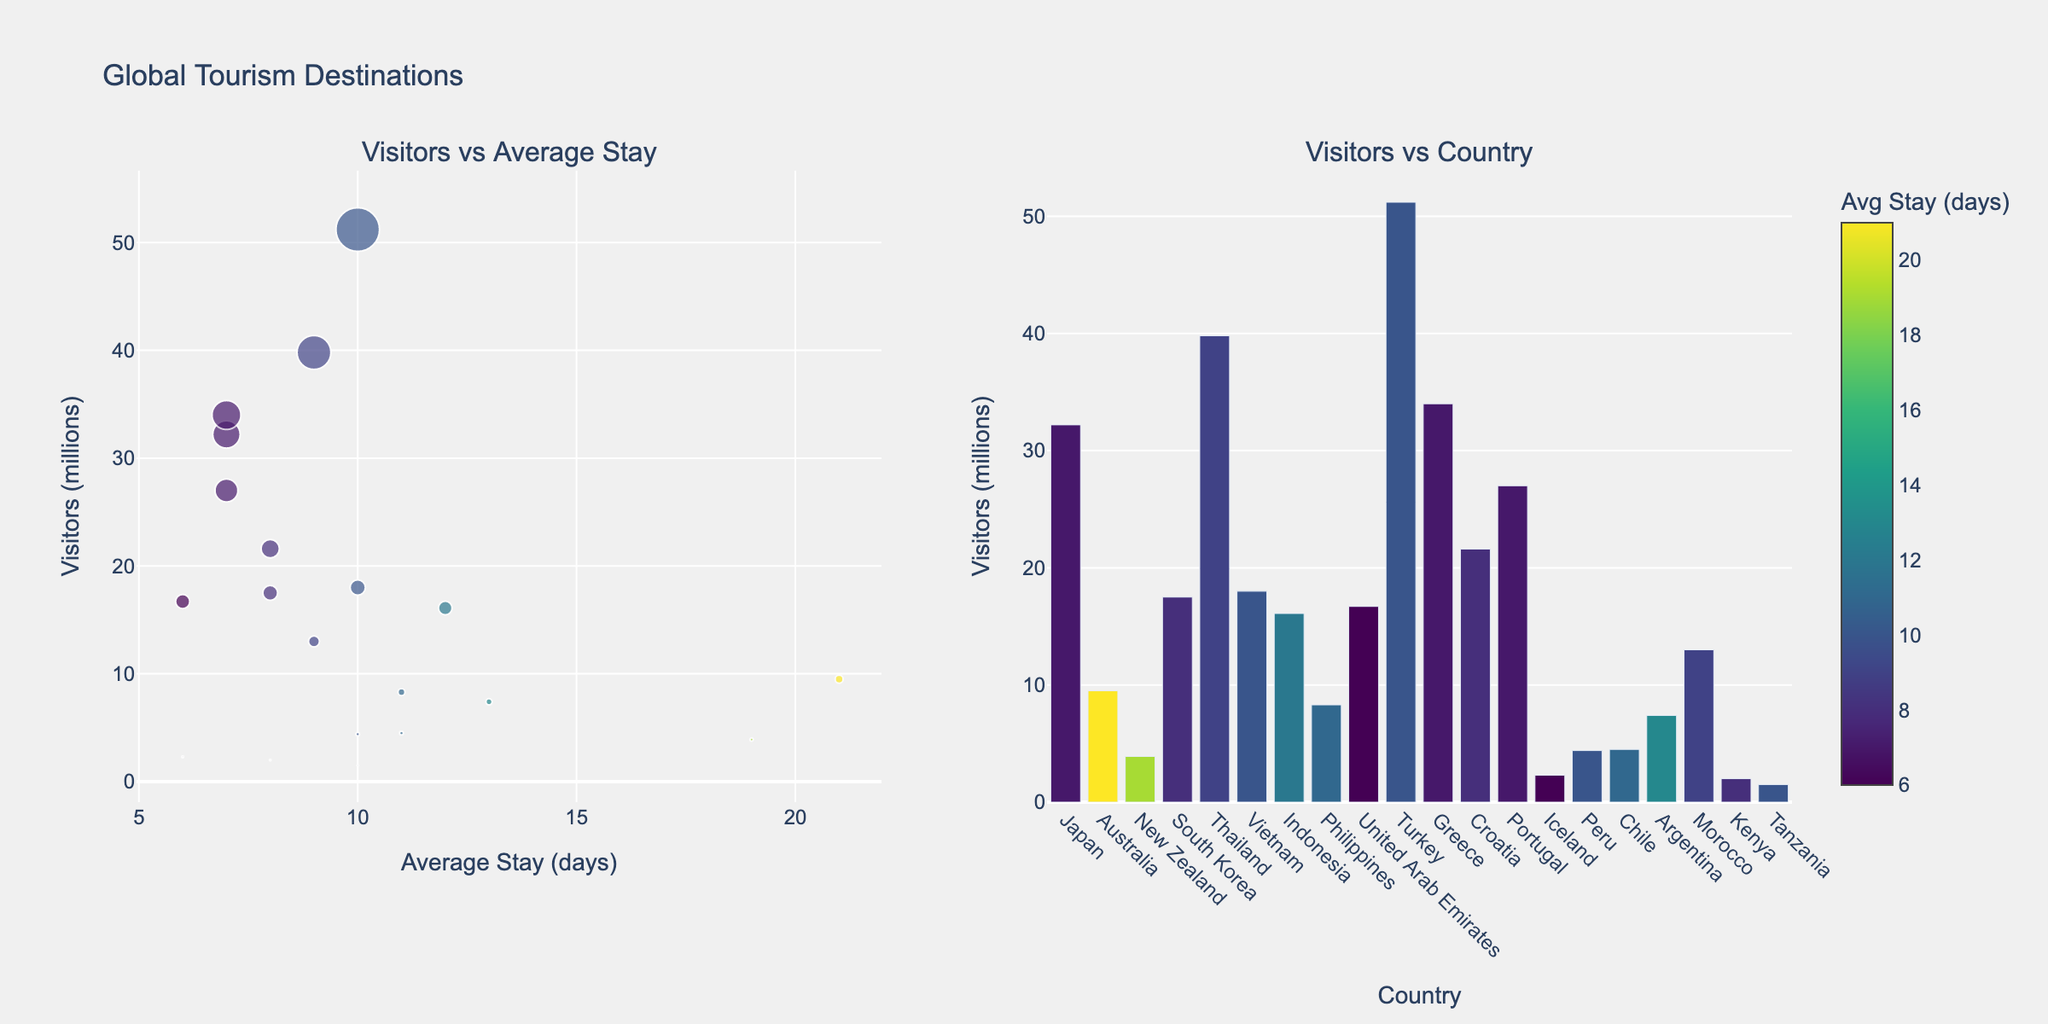What is the title of the figure? The title is usually placed at the top of the figure, summarizing the content of the visualization. In this case, it reads "Funding Rounds for Unicorn Startups Across Tech Sectors".
Answer: Funding Rounds for Unicorn Startups Across Tech Sectors Which company received the highest Series C funding? To find this, look at the height of the Series C bars across all subplots. The tallest bar represents OpenAI with $11,300M.
Answer: OpenAI What's the total amount of funding received by Stripe across all rounds? Sum the values for Stripe across Seed ($0.02M), Series A ($18M), Series B ($150M), and Series C ($600M). Total = 0.02 + 18 + 150 + 600.
Answer: $768.02M Among the displayed sectors, which one had the highest initial seed funding? Compare the heights of the Seed bars across sectors. Aurora in Autonomous Vehicles has the highest Seed funding with $5.4M.
Answer: Autonomous Vehicles (Aurora) Compare the Series A and Series B funding for Byju's and find the difference. Subtract the Series A funding for Byju's ($9M) from the Series B funding ($75M). Difference = 75 - 9.
Answer: $66M Which sector shows the least variation in funding amounts across all rounds? To determine variation, visually inspect the differences in bar heights within each subplot. The Cybersecurity sector (Snyk) has relatively low and closely clustered funding amounts.
Answer: Cybersecurity What is the average Series C funding across all sectors? Add the Series C values for all companies and divide by the number of companies. Total Series C = 11300+600+300+871+1000+400+1000+540+1900+300 = 18511. Average = 18511 / 10.
Answer: $1,851.1M Which sector had the highest funding increase between Series A and Series B? Calculate the increase (Series B - Series A) for each sector and find the maximum. OpenAI (AI) had an increase of $1,000M - $160M = $840M.
Answer: AI (OpenAI) How does the Series A funding for Fintech (Stripe) compare to Series A for Blockchain (Coinbase)? Look at the Series A bars for Stripe and Coinbase. Stripe has $18M, and Coinbase has $25M, thus Coinbase's Series A is higher.
Answer: Coinbase's is higher Which company has a consistent increase in funding across all rounds? Inspect each company’s bars across all rounds for consistent upward trends. Databricks shows a constant increase from Seed to Series C.
Answer: Databricks 